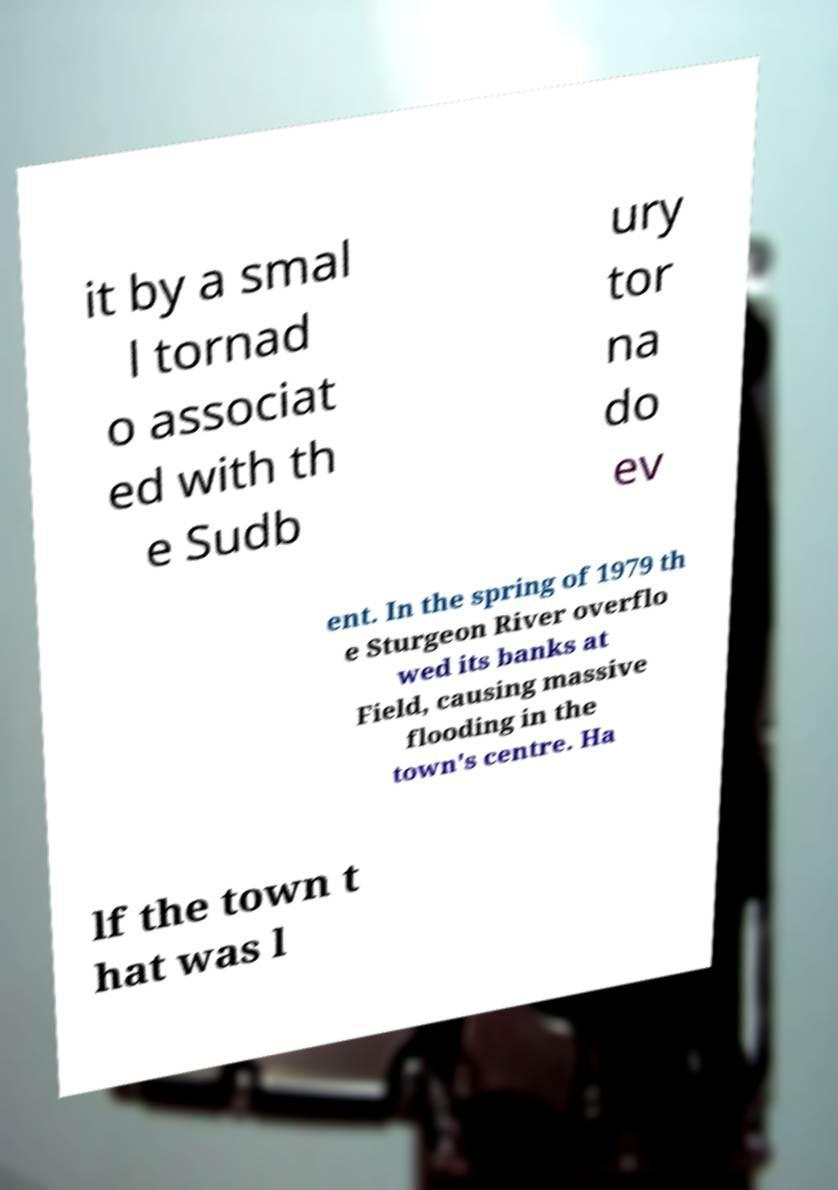For documentation purposes, I need the text within this image transcribed. Could you provide that? it by a smal l tornad o associat ed with th e Sudb ury tor na do ev ent. In the spring of 1979 th e Sturgeon River overflo wed its banks at Field, causing massive flooding in the town's centre. Ha lf the town t hat was l 